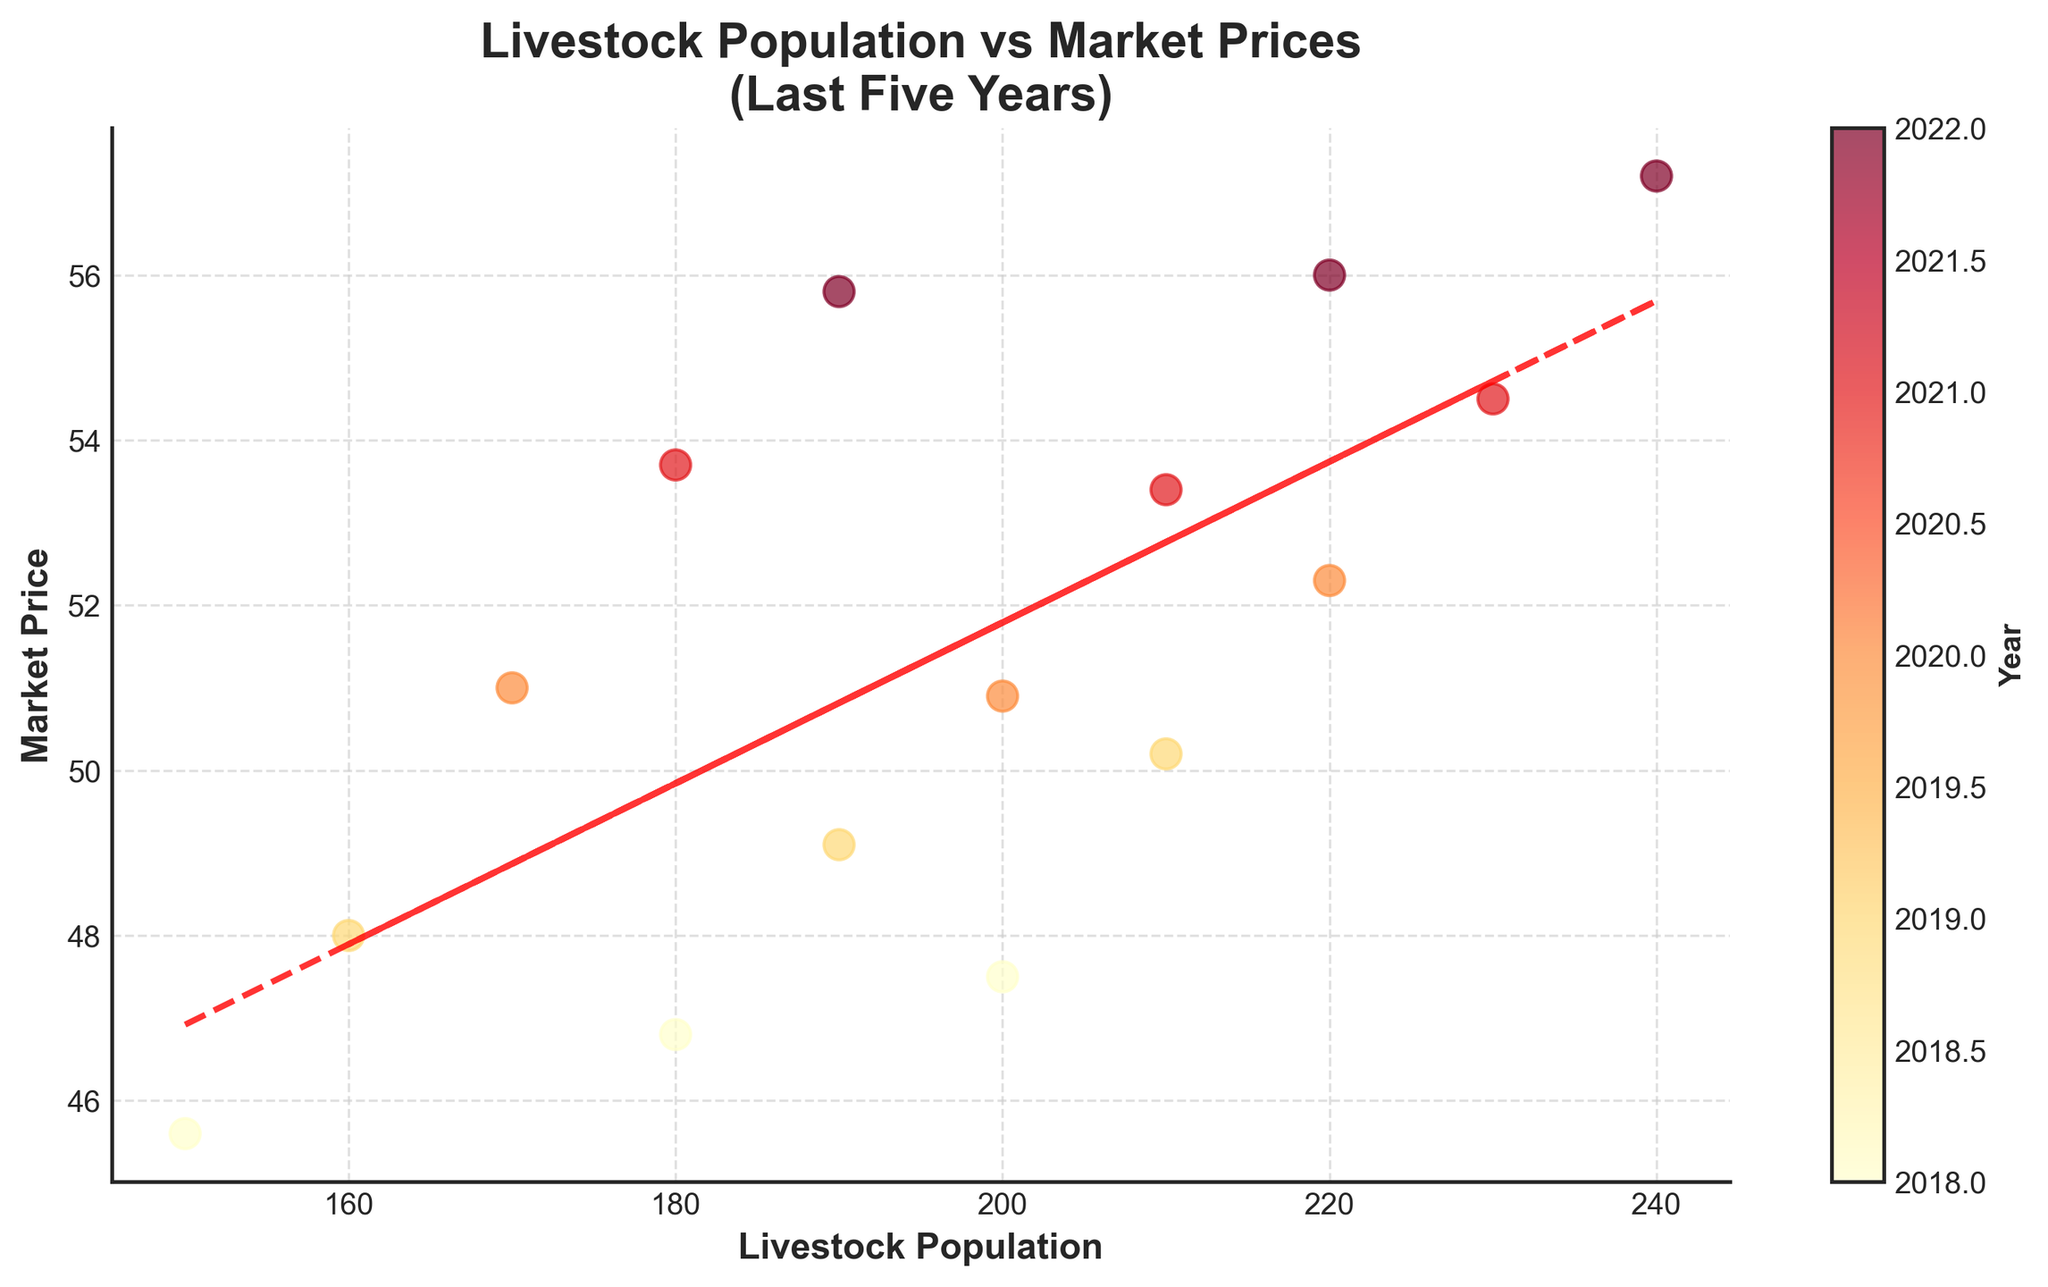What's the title of the figure? The title is usually found at the top of the figure. It summarizes what the figure represents. In this case, it states the relationship between livestock population and market prices over the last five years.
Answer: Livestock Population vs Market Prices (Last Five Years) How many years of data are represented in the figure? The number of unique colors or the color bar indicates different years. The figure shows data from 2018 to 2022, which is five years in total.
Answer: Five years What does the x-axis represent? The x-axis label is usually found at the bottom of the horizontal axis. In this figure, it indicates the livestock population.
Answer: Livestock Population Which year had the highest market price based on color indication? The color bar shows that the year 2022 corresponds to the highest values on the color spectrum. The points with the highest market prices are in the colors that represent 2022.
Answer: 2022 What can you infer about the relationship between livestock population and market prices from the trend line? The trend line indicates the overall direction of the data points. A positive slope, as shown in the figure, suggests that as the livestock population increases, the market price also tends to increase.
Answer: Positive relationship Which year shows the lowest market price, and what is that price? The color bar and the scatter plot’s vertical (y-axis) values show that the year 2018 had the lowest market prices. The lowest point in 2018 is 45.60.
Answer: 2018, 45.60 What is the approximate increase in the market price from 2020 to 2021 for a livestock population of around 210? Find the points corresponding to 2020 and 2021 around 210 on the x-axis. The market price increases from about 50.90 in 2020 to 53.40 in 2021. The difference is approximately 53.40 - 50.90 = 2.50.
Answer: 2.50 Comparing 2018 and 2022, which year had a higher range of market prices? Check the spread of points within each year's color code. 2018 has prices ranging around 45.60 to 47.50, while 2022 ranges from 55.80 to 57.20. The range for 2022 is wider.
Answer: 2022 How does the market price change as the livestock population goes from 150 to 240? Follow the trend line and the scatter plot. Starting from a population of 150 to 240, the market price increases, as indicated by both the scatter points and the upward slope of the trend line.
Answer: Increases What is the equation of the trend line? A polynomial fit (linear trend line) equation is indicated by the red dashed line. The equation can be calculated by polyfit, which we know based on data details. Given a trend line, it resembles y = mx + c, where coefficients determine the slope and intercept. In context, it indicates how much price changes with population.
Answer: y = mx + c 